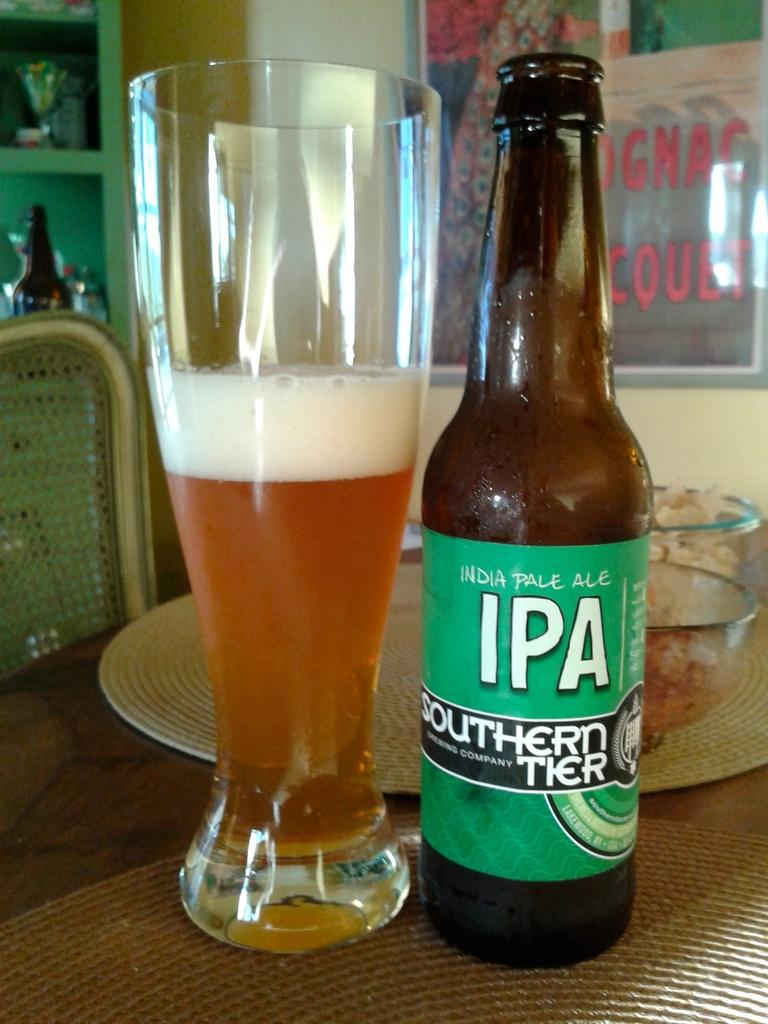<image>
Give a short and clear explanation of the subsequent image. bottle of india pale ale IPA southern tier next to a half full glass 